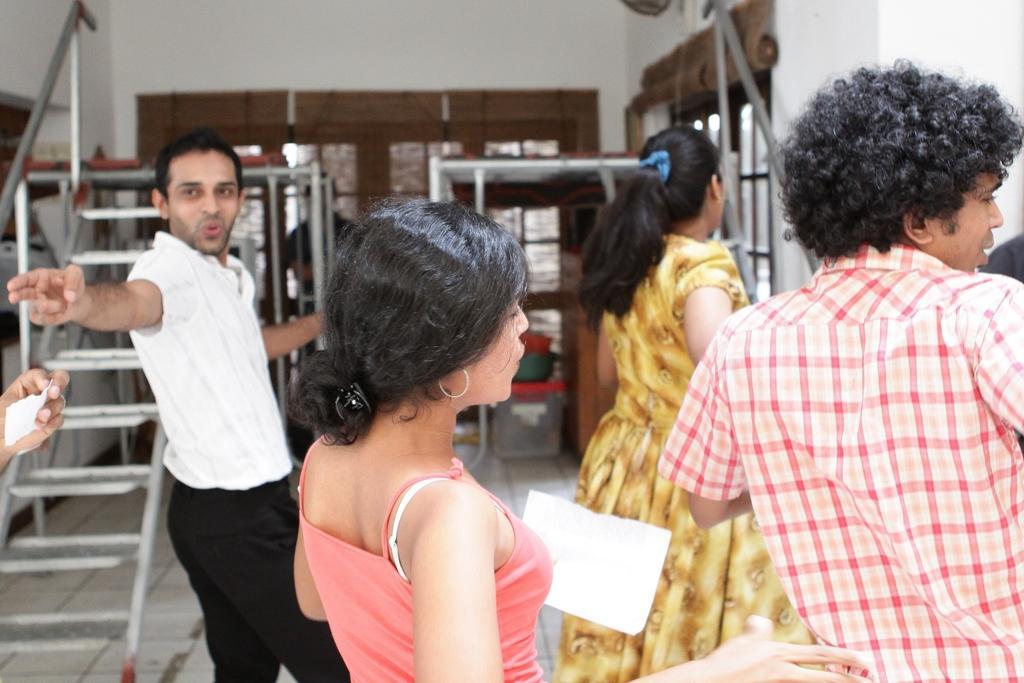Could you give a brief overview of what you see in this image? In the background we can see the wall. In this picture we can see windows, ladder, people, floor and few objects. We can see a woman is holding a paper. On the left side of the picture we can see a person's hand holding a paper. 